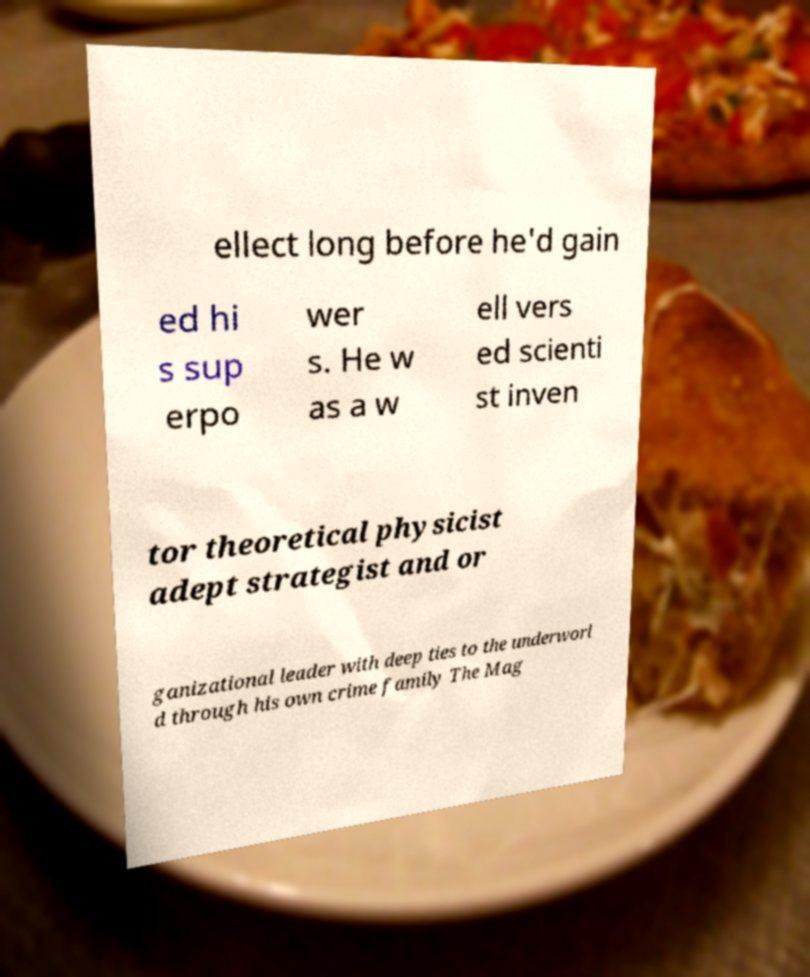Can you read and provide the text displayed in the image?This photo seems to have some interesting text. Can you extract and type it out for me? ellect long before he'd gain ed hi s sup erpo wer s. He w as a w ell vers ed scienti st inven tor theoretical physicist adept strategist and or ganizational leader with deep ties to the underworl d through his own crime family The Mag 